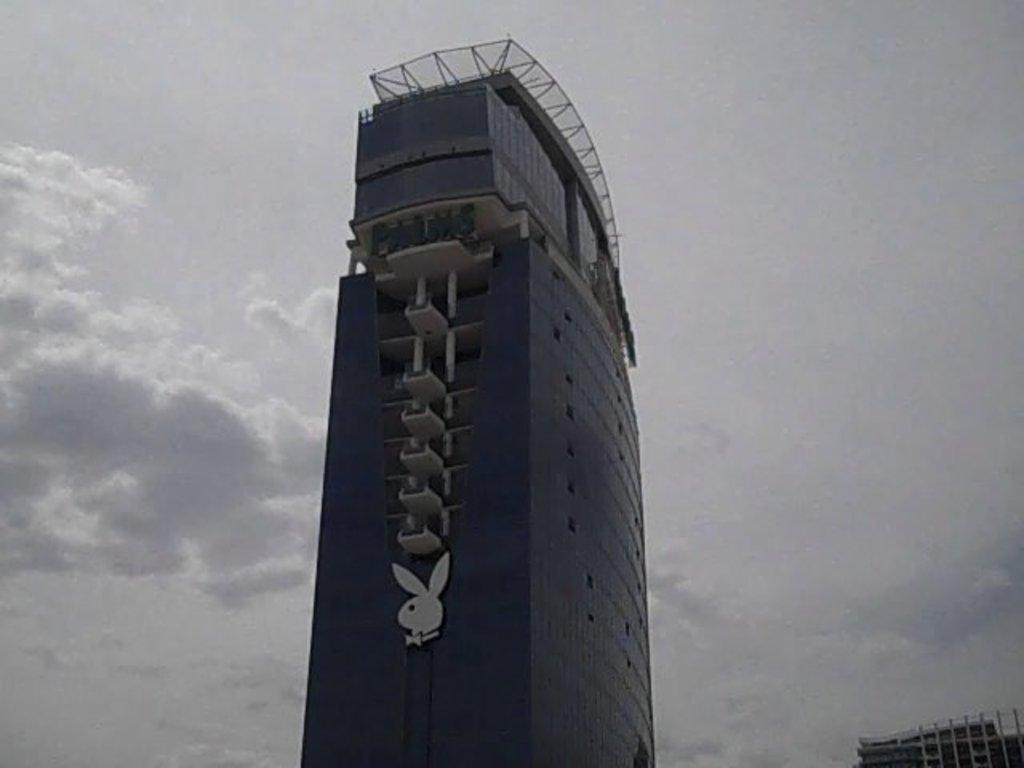Can you describe this image briefly? This image is taken outdoors. At the top of the image there is a sky with clouds. At the right bottom of the image there is a building. In the middle of the image there is a skyscraper with glass, windows, a roof, pillars, balconies and railings. 